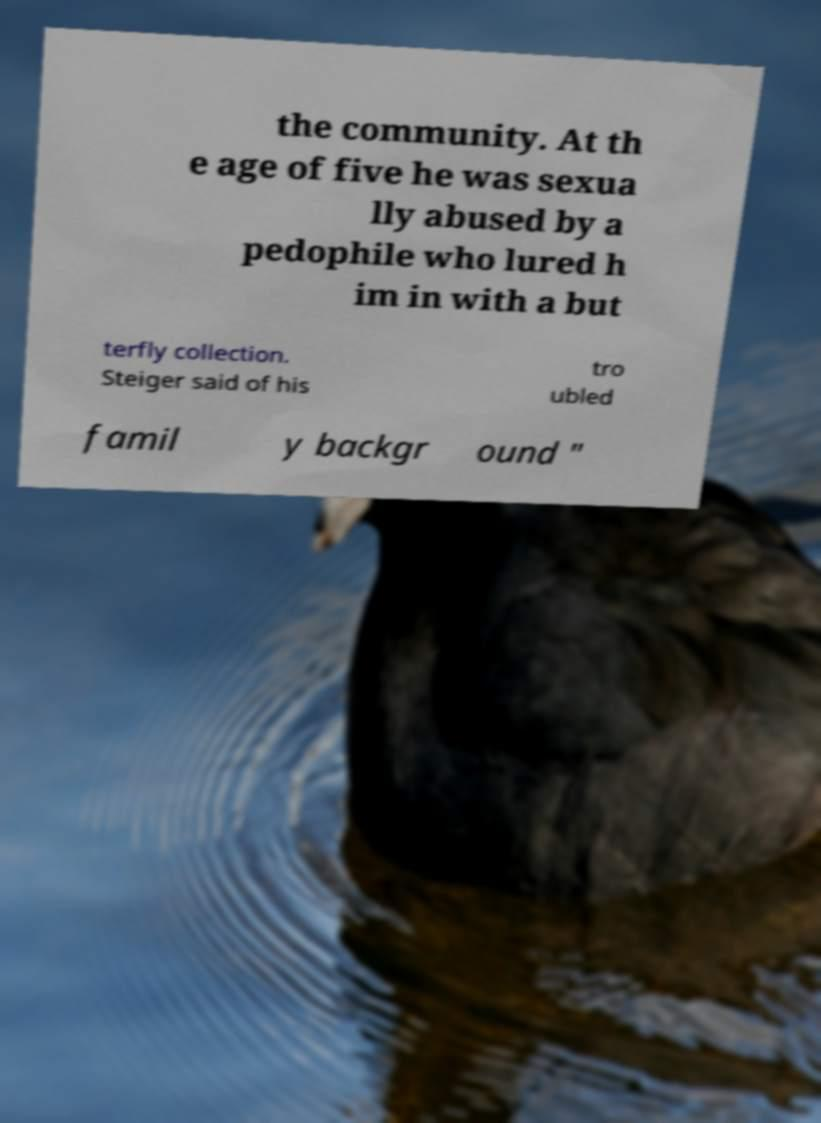There's text embedded in this image that I need extracted. Can you transcribe it verbatim? the community. At th e age of five he was sexua lly abused by a pedophile who lured h im in with a but terfly collection. Steiger said of his tro ubled famil y backgr ound " 